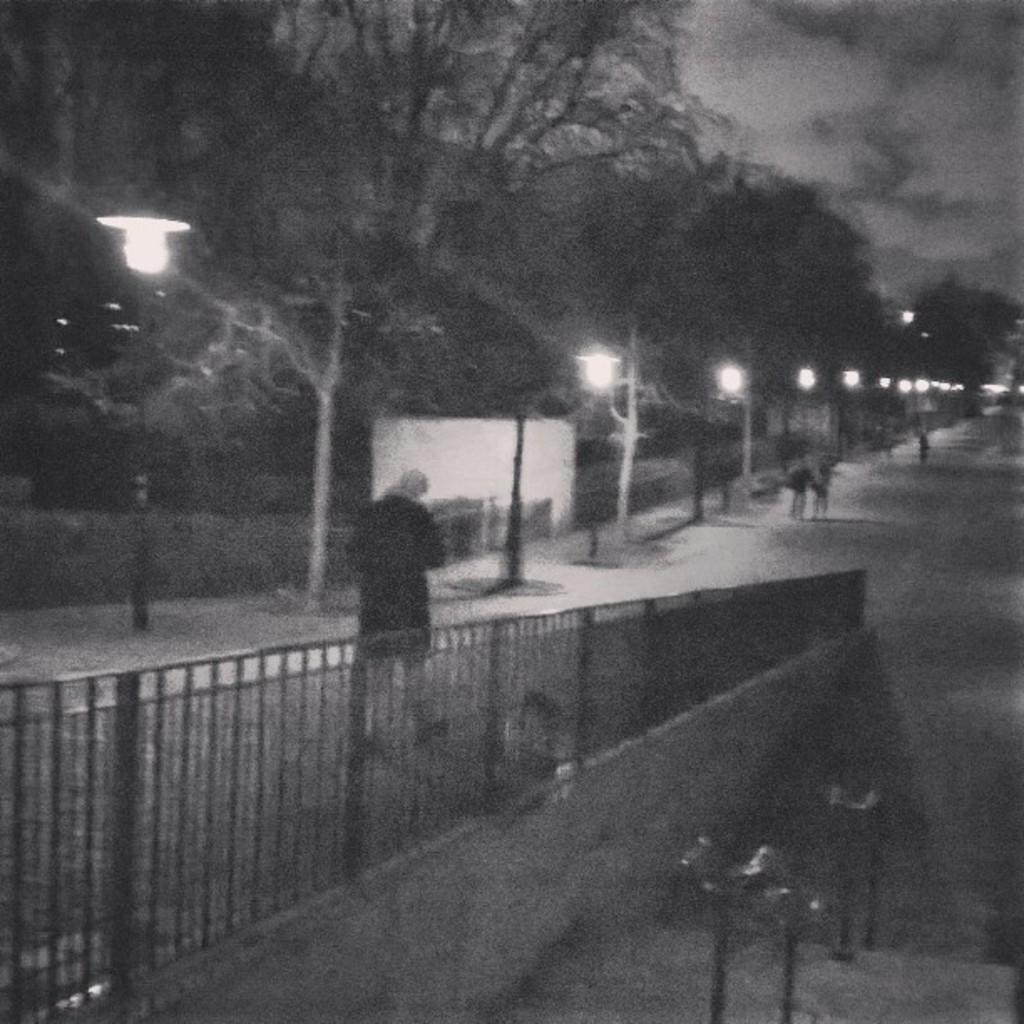In one or two sentences, can you explain what this image depicts? In this image in the center there is a fence and there is a person walking. In the background there are poles and there are lights on the poles and there are persons and trees and the sky is cloudy and in the front there are objects which are black in colour. 